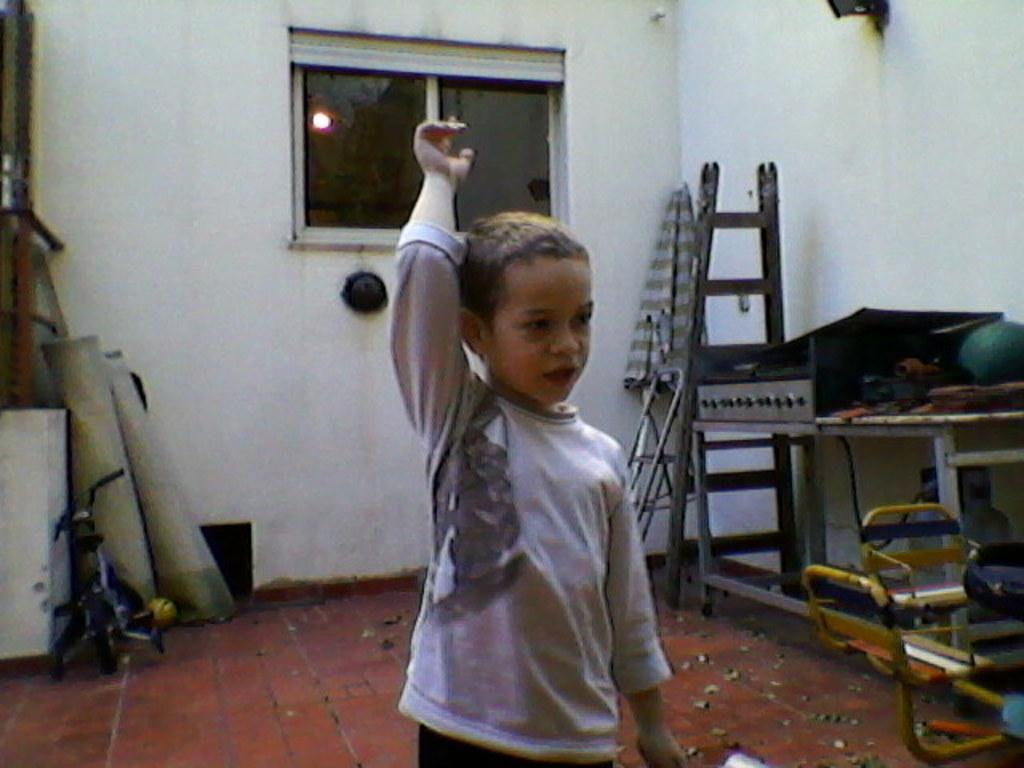In one or two sentences, can you explain what this image depicts? In the center of the image there is a boy. In the background of the image there is a wall. There is a window. To the right side of the image there are objects. To the left side of the image there is a bicycle and there are some other objects. At the bottom of the image there is floor. 